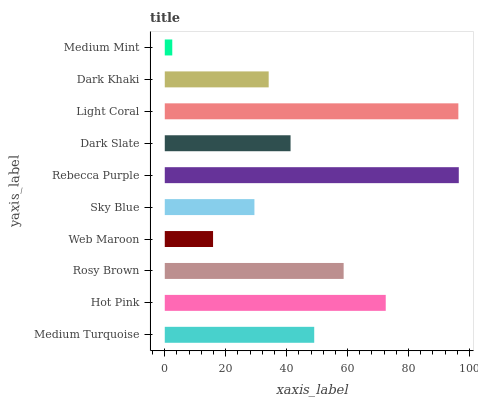Is Medium Mint the minimum?
Answer yes or no. Yes. Is Rebecca Purple the maximum?
Answer yes or no. Yes. Is Hot Pink the minimum?
Answer yes or no. No. Is Hot Pink the maximum?
Answer yes or no. No. Is Hot Pink greater than Medium Turquoise?
Answer yes or no. Yes. Is Medium Turquoise less than Hot Pink?
Answer yes or no. Yes. Is Medium Turquoise greater than Hot Pink?
Answer yes or no. No. Is Hot Pink less than Medium Turquoise?
Answer yes or no. No. Is Medium Turquoise the high median?
Answer yes or no. Yes. Is Dark Slate the low median?
Answer yes or no. Yes. Is Hot Pink the high median?
Answer yes or no. No. Is Sky Blue the low median?
Answer yes or no. No. 